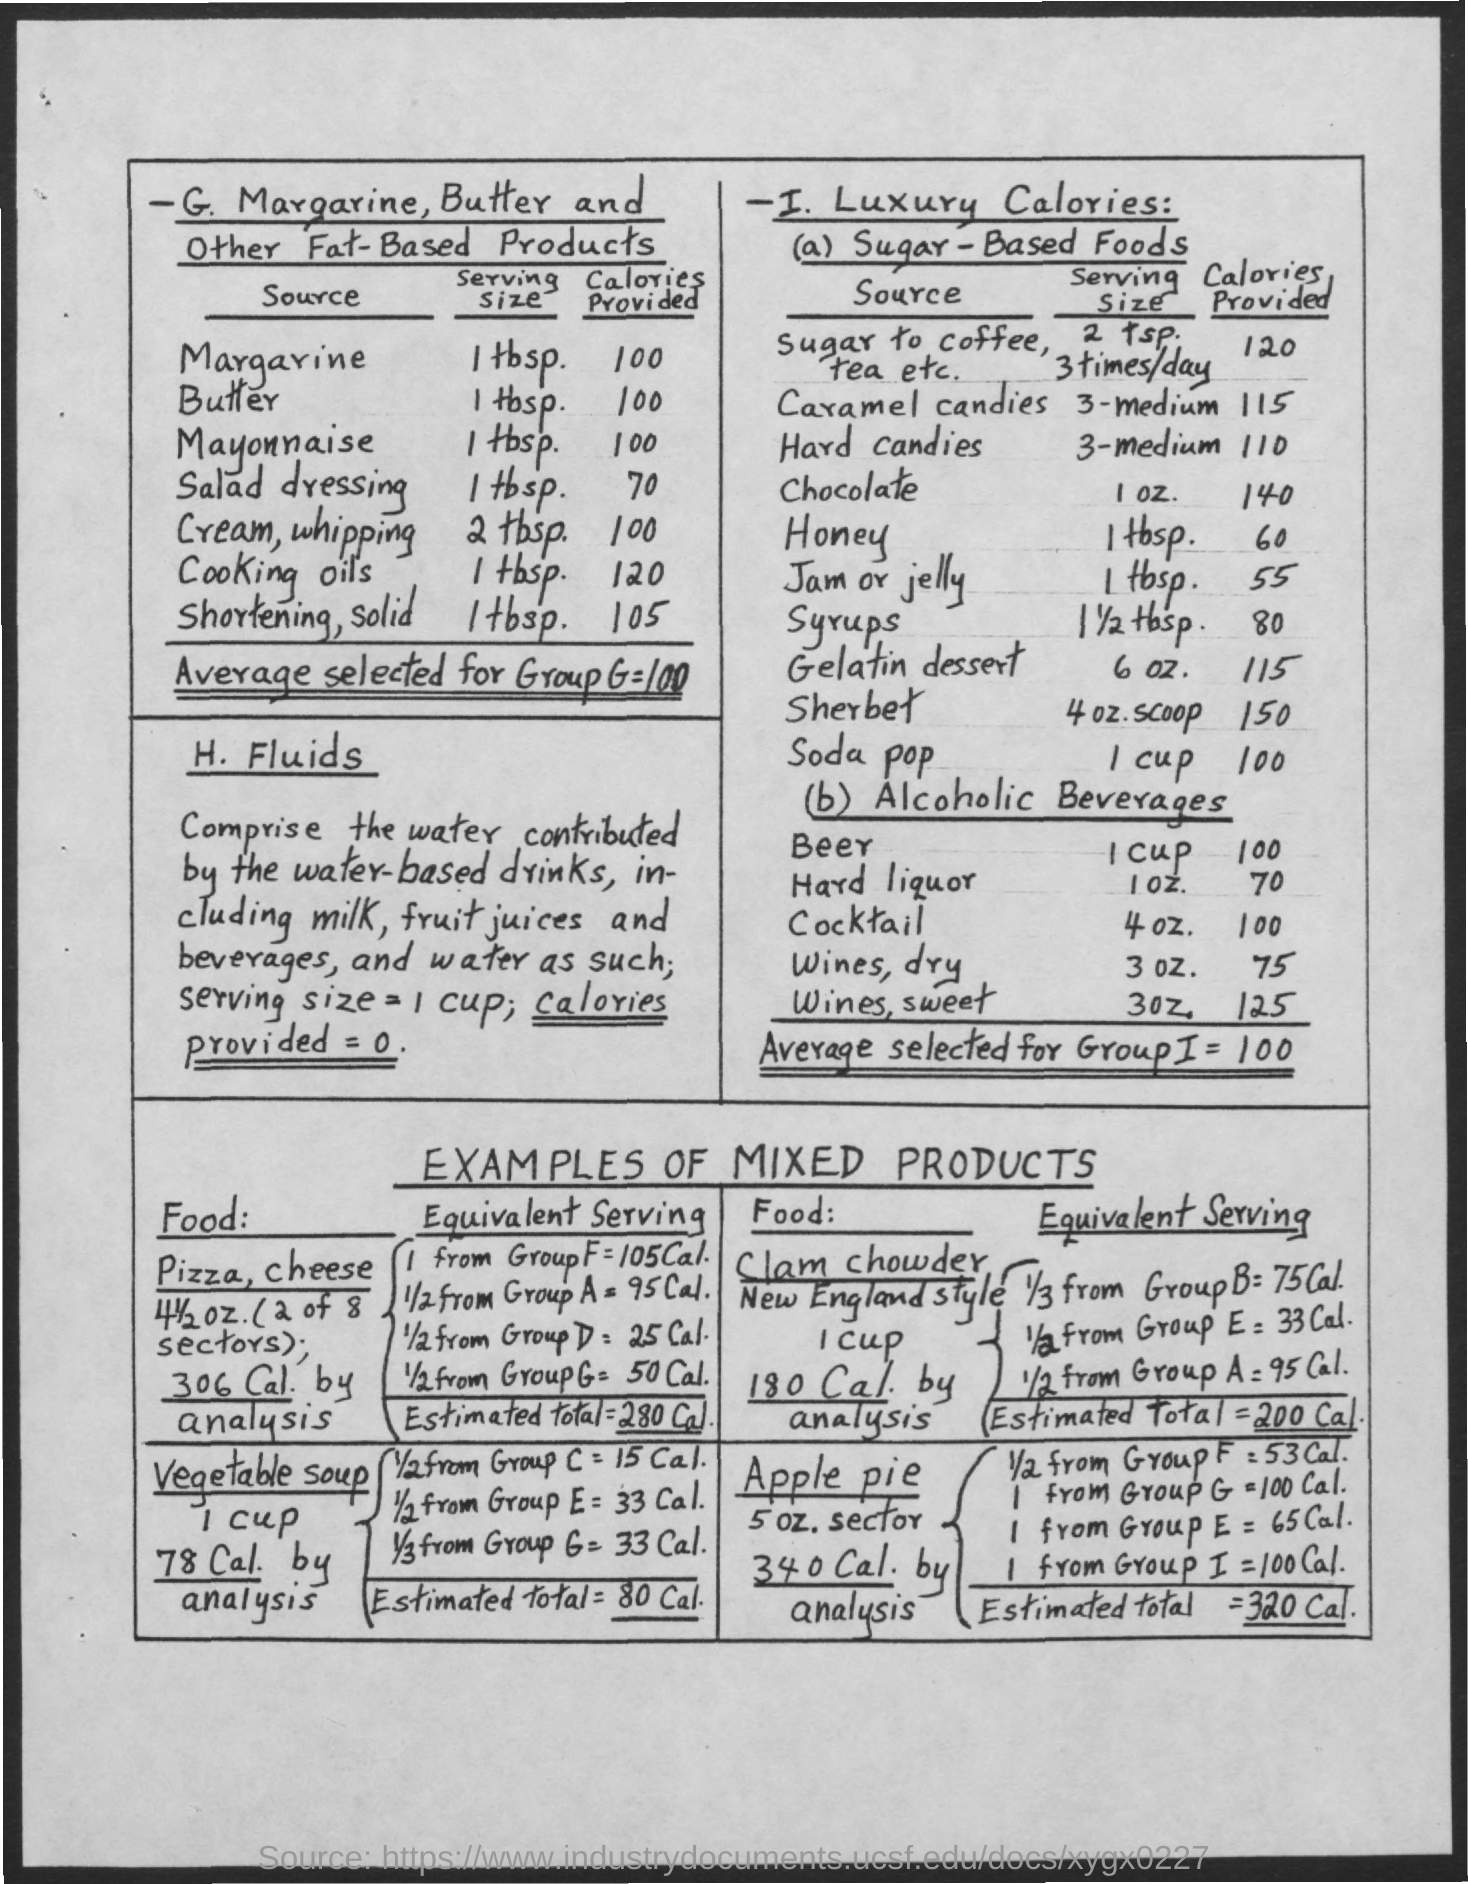Point out several critical features in this image. The amount of calories contained in 1 tablespoon of butter is 100 calories. The average selected for group G is 100. How many calories does one tablespoon of margarine provide? It is 100 calories. 1 tablespoon of salad dressing contains approximately 70 calories. 1 tbsp of cooking oils provides approximately 120 calories. 